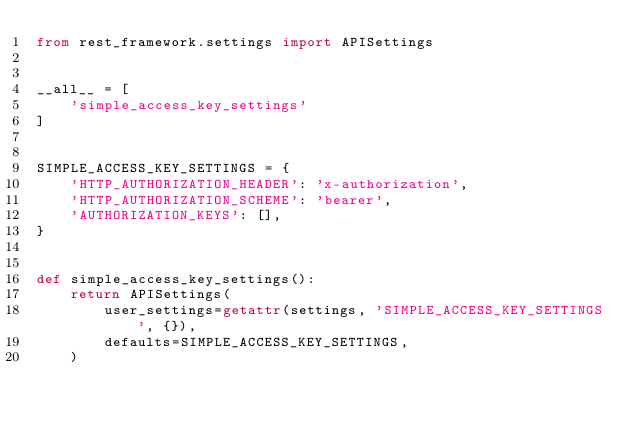<code> <loc_0><loc_0><loc_500><loc_500><_Python_>from rest_framework.settings import APISettings


__all__ = [
    'simple_access_key_settings'
]


SIMPLE_ACCESS_KEY_SETTINGS = {
    'HTTP_AUTHORIZATION_HEADER': 'x-authorization',
    'HTTP_AUTHORIZATION_SCHEME': 'bearer',
    'AUTHORIZATION_KEYS': [],
}


def simple_access_key_settings():
    return APISettings(
        user_settings=getattr(settings, 'SIMPLE_ACCESS_KEY_SETTINGS', {}),
        defaults=SIMPLE_ACCESS_KEY_SETTINGS,
    )
</code> 